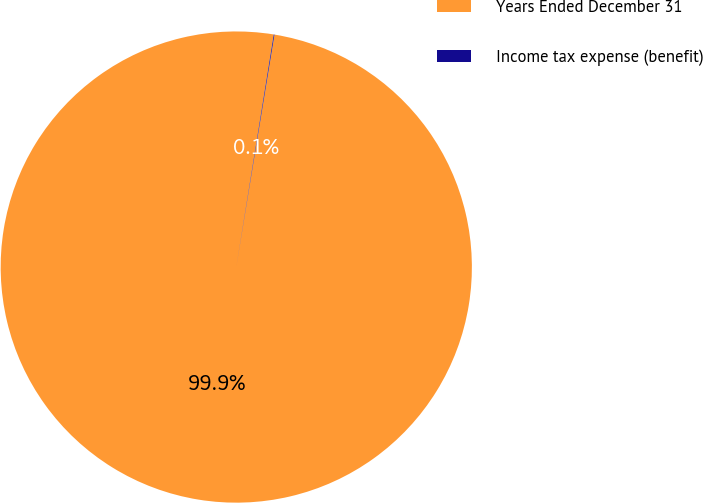<chart> <loc_0><loc_0><loc_500><loc_500><pie_chart><fcel>Years Ended December 31<fcel>Income tax expense (benefit)<nl><fcel>99.95%<fcel>0.05%<nl></chart> 